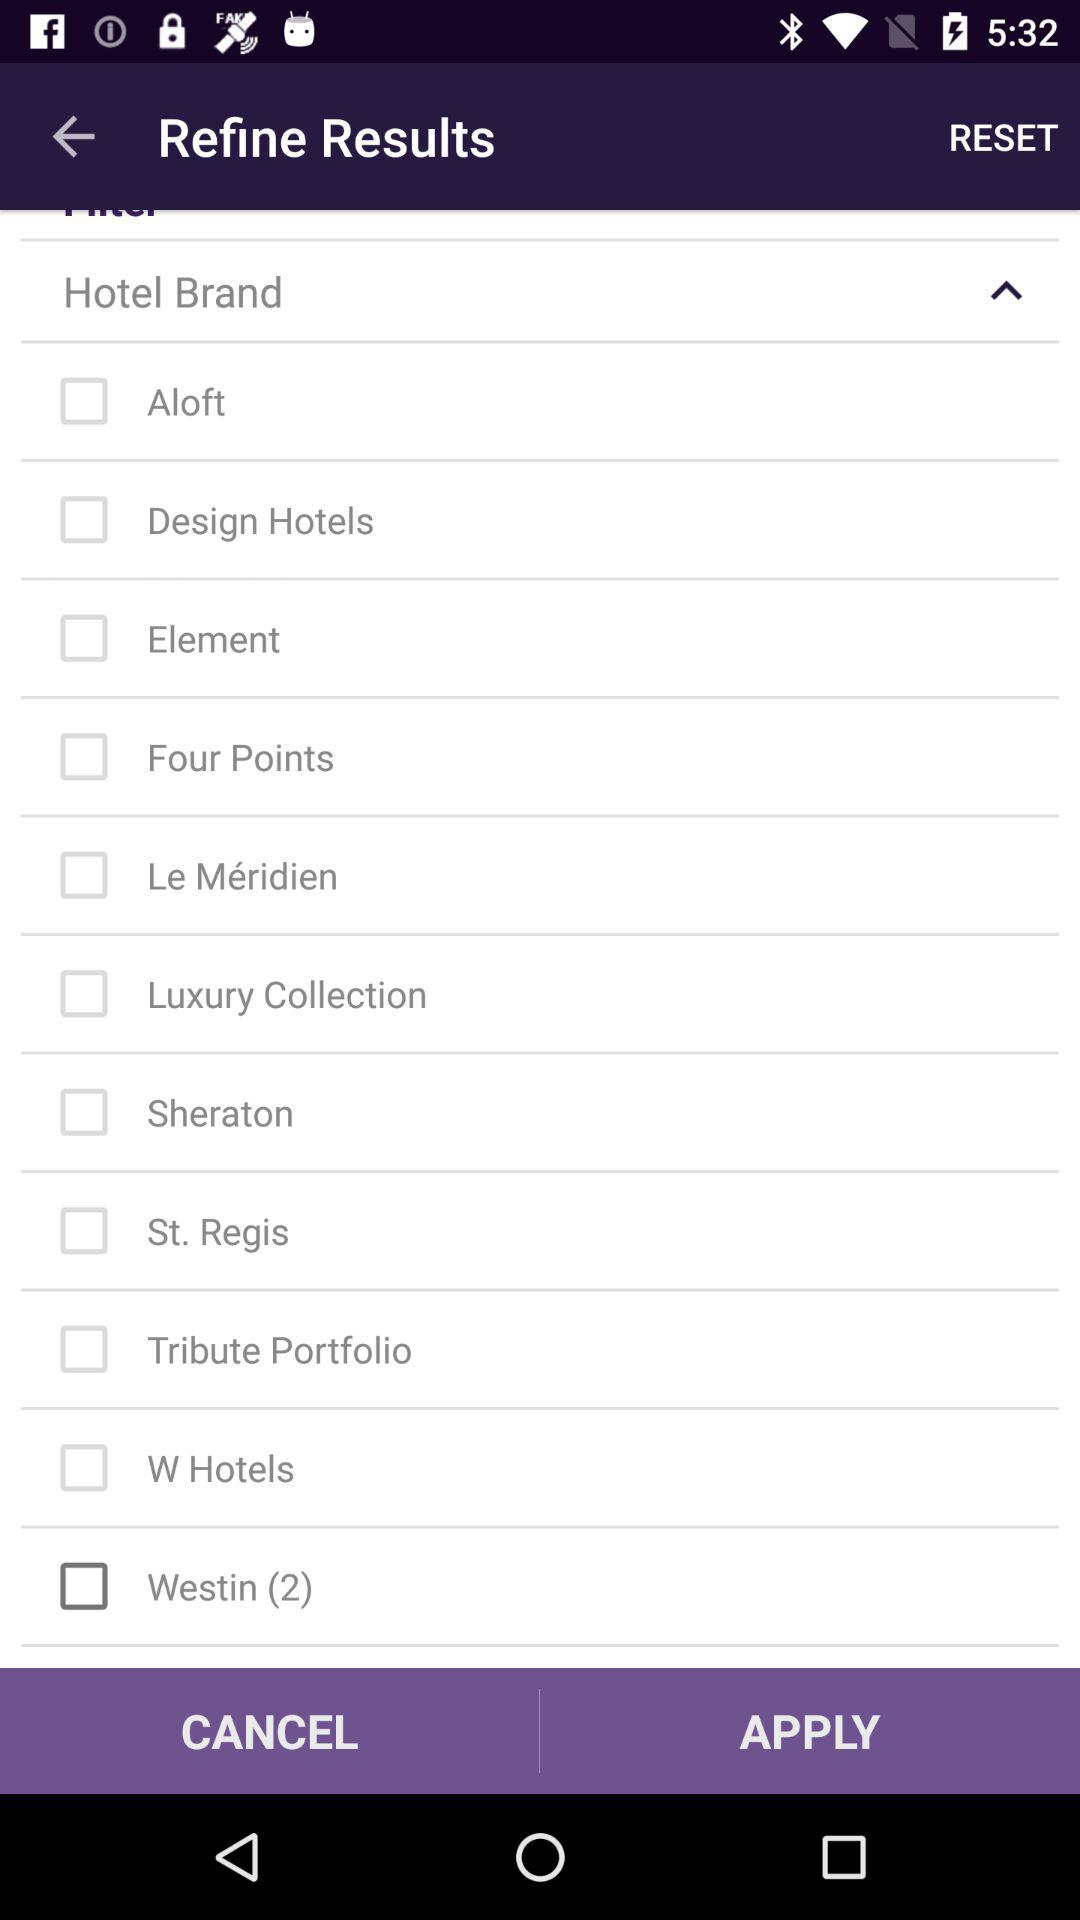What is the status of "Aloft"? The status of "Aloft" is "offf". 